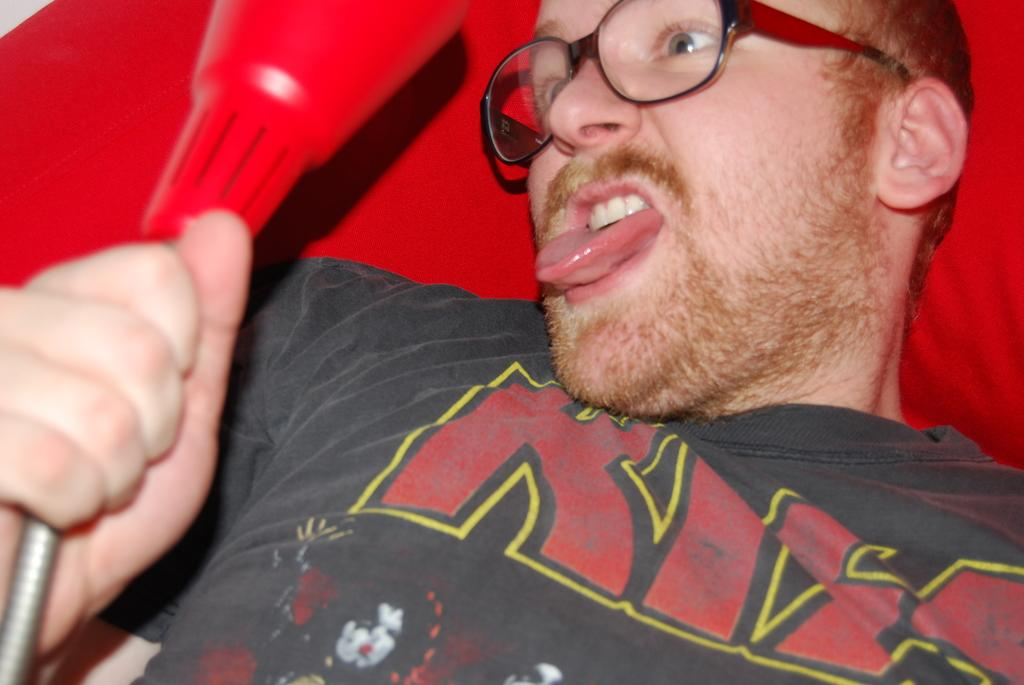What is present in the image? There is a man in the image. What is the man doing in the image? The man is holding an object in his hand. What is the effect of the chin on the time in the image? There is no chin or time mentioned in the image, so it is not possible to determine any effect. 